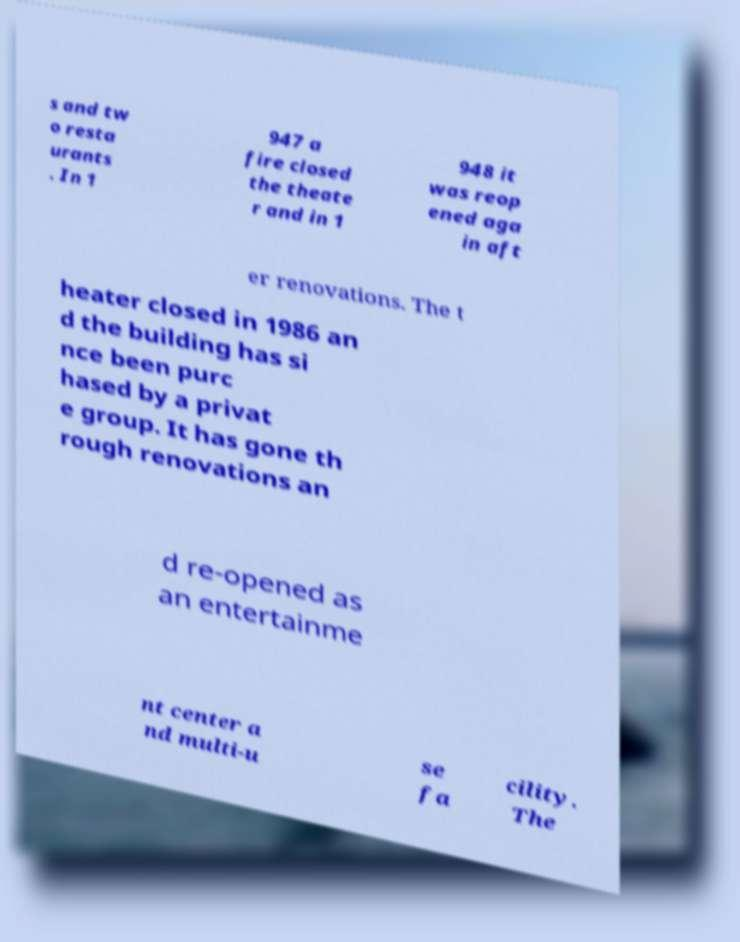I need the written content from this picture converted into text. Can you do that? s and tw o resta urants . In 1 947 a fire closed the theate r and in 1 948 it was reop ened aga in aft er renovations. The t heater closed in 1986 an d the building has si nce been purc hased by a privat e group. It has gone th rough renovations an d re-opened as an entertainme nt center a nd multi-u se fa cility. The 